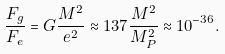Convert formula to latex. <formula><loc_0><loc_0><loc_500><loc_500>\frac { F _ { g } } { F _ { e } } = G \frac { M ^ { 2 } } { e ^ { 2 } } \approx 1 3 7 \frac { M ^ { 2 } } { M _ { P } ^ { 2 } } \approx 1 0 ^ { - 3 6 } .</formula> 